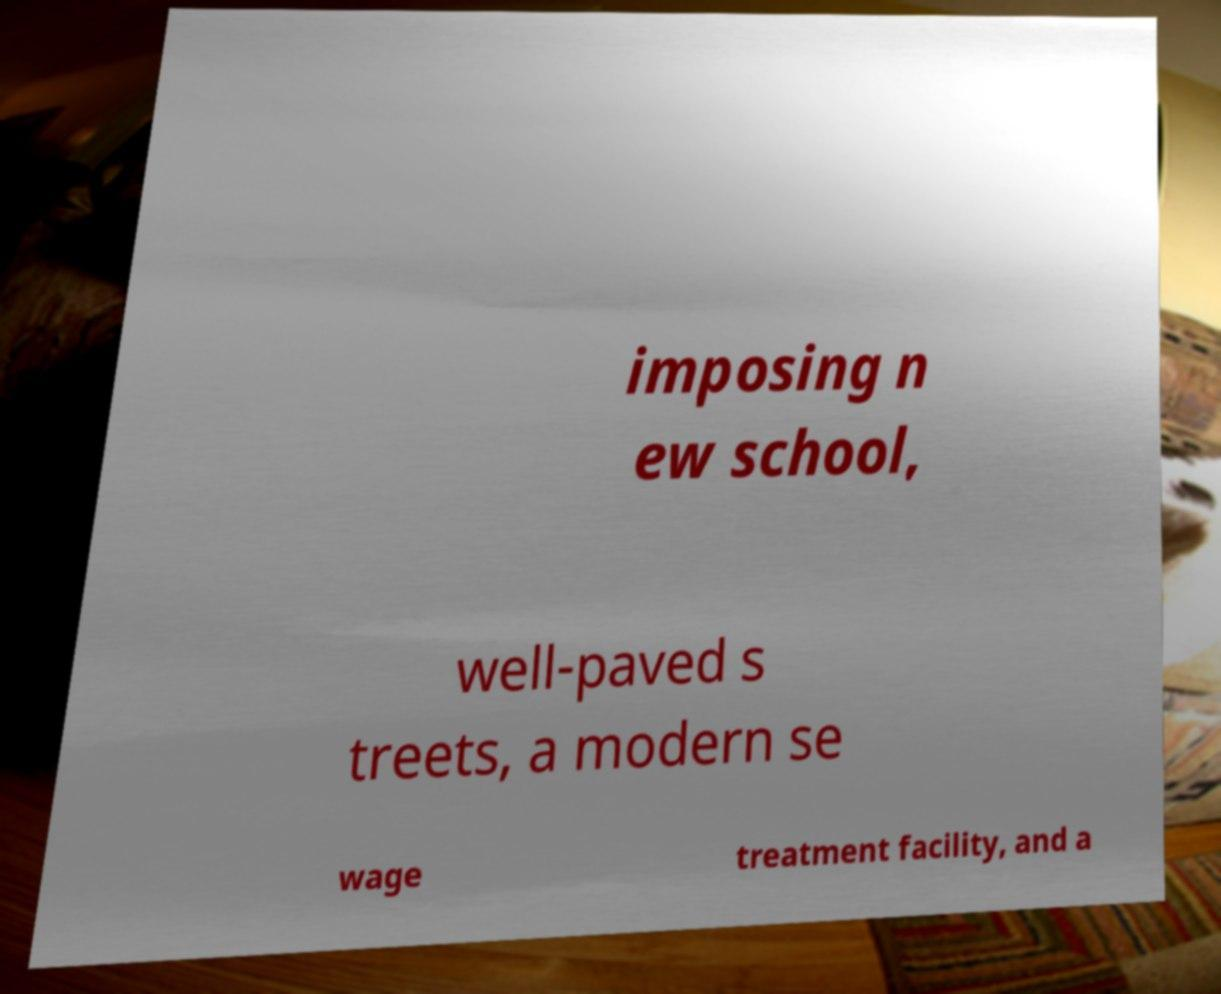For documentation purposes, I need the text within this image transcribed. Could you provide that? imposing n ew school, well-paved s treets, a modern se wage treatment facility, and a 